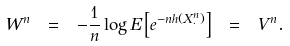Convert formula to latex. <formula><loc_0><loc_0><loc_500><loc_500>W ^ { n } \ = \ - \frac { 1 } { n } \log E \left [ e ^ { - n h ( X ^ { n } _ { \cdot } ) } \right ] \ = \ V ^ { n } .</formula> 